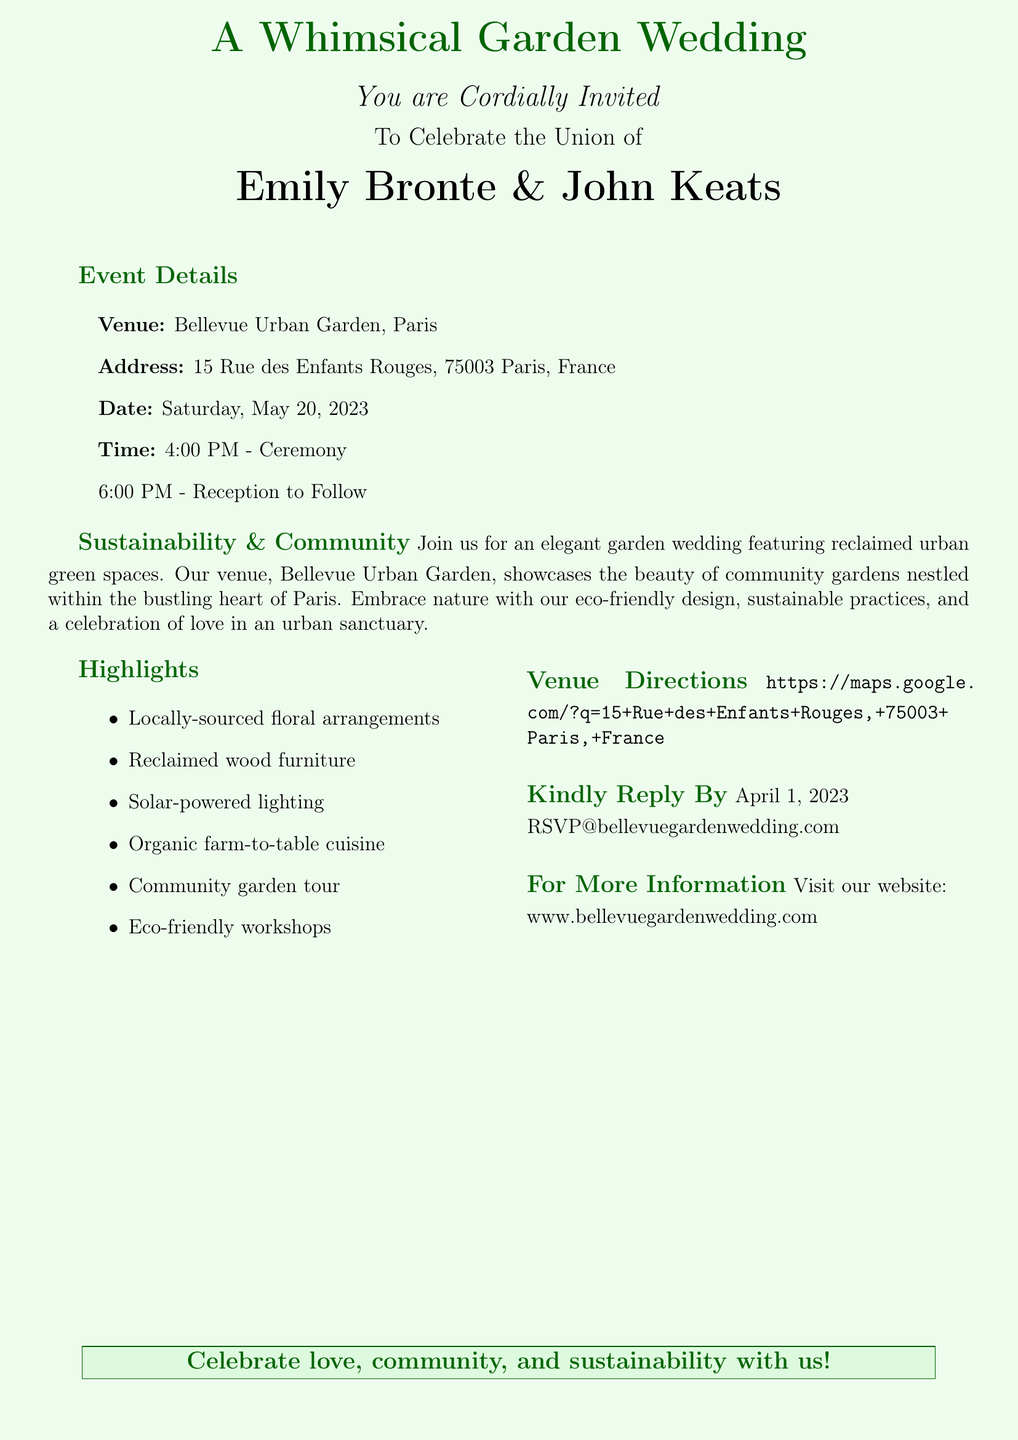What is the date of the wedding? The date is explicitly mentioned in the event details section of the invitation.
Answer: Saturday, May 20, 2023 Who are the couple getting married? The invitation includes the names of the couple prominently near the center.
Answer: Emily Bronte & John Keats Where is the venue located? The venue address is provided in the event details.
Answer: 15 Rue des Enfants Rouges, 75003 Paris, France What is one of the highlights of the wedding? The document lists several highlights, emphasizing eco-friendly themes.
Answer: Locally-sourced floral arrangements What is the RSVP deadline? The RSVP date is specified clearly in the invitation.
Answer: April 1, 2023 What type of cuisine will be served? The invitation mentions a specific catering style as part of the highlights.
Answer: Organic farm-to-table cuisine What sustainable feature is included in the decoration? The document mentions specific materials used that are eco-friendly.
Answer: Reclaimed wood furniture In which city is the Bellevue Urban Garden located? The invitation indicates the city in the venue section.
Answer: Paris What is the theme of the wedding? The theme is repeated at various points throughout the invitation.
Answer: Sustainability and community 